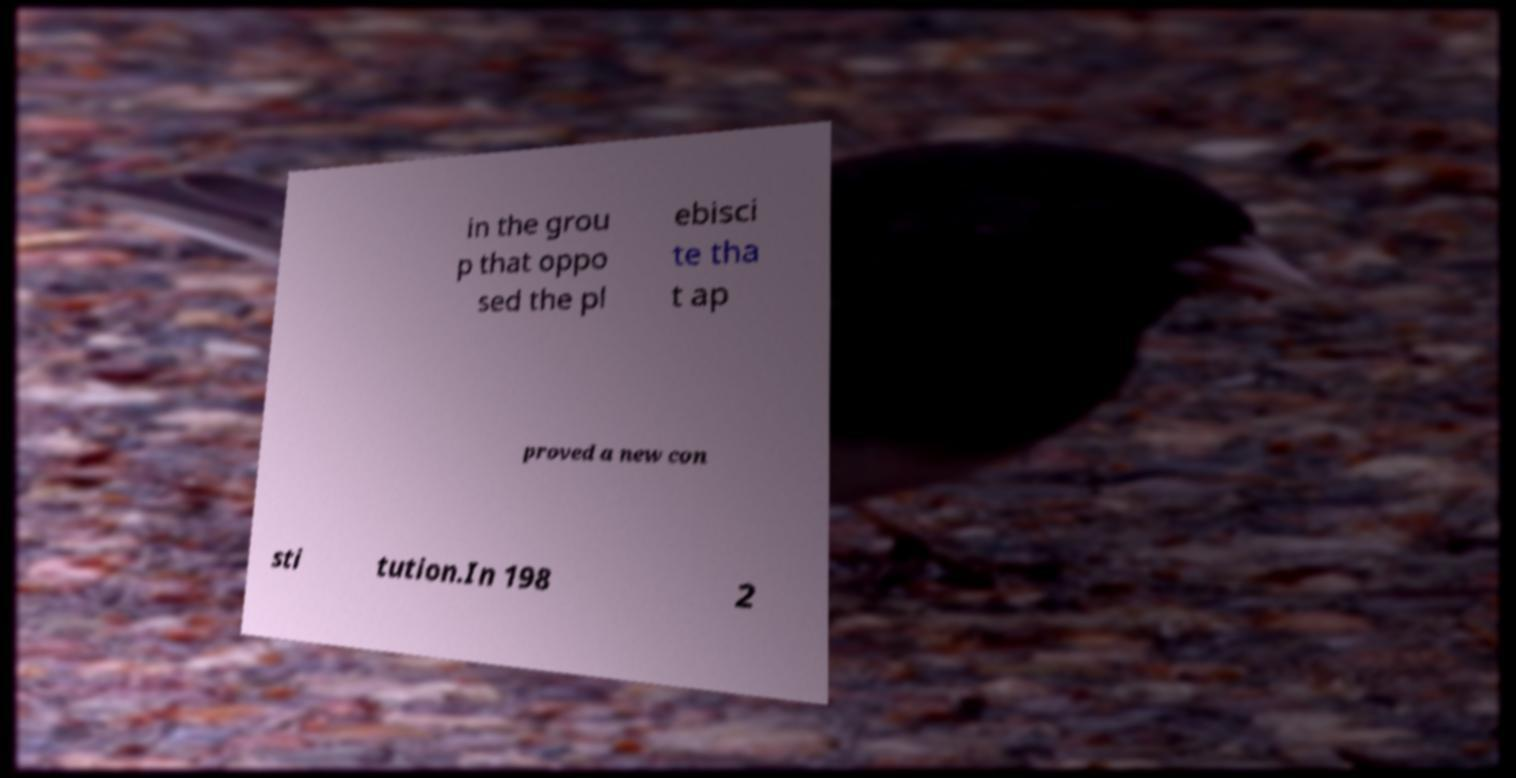What messages or text are displayed in this image? I need them in a readable, typed format. in the grou p that oppo sed the pl ebisci te tha t ap proved a new con sti tution.In 198 2 